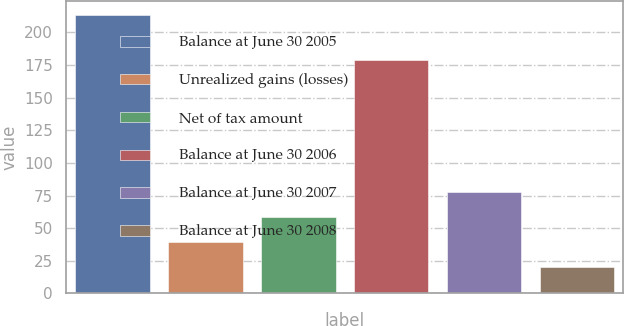Convert chart to OTSL. <chart><loc_0><loc_0><loc_500><loc_500><bar_chart><fcel>Balance at June 30 2005<fcel>Unrealized gains (losses)<fcel>Net of tax amount<fcel>Balance at June 30 2006<fcel>Balance at June 30 2007<fcel>Balance at June 30 2008<nl><fcel>213<fcel>39.3<fcel>58.6<fcel>179<fcel>77.9<fcel>20<nl></chart> 